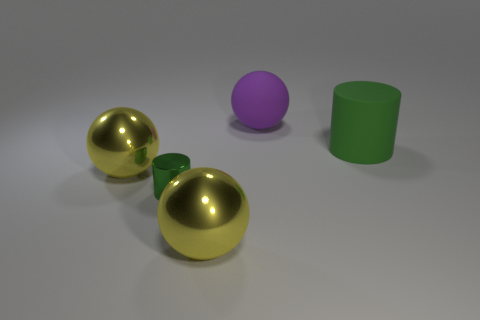Add 5 tiny red metal cylinders. How many objects exist? 10 Subtract all yellow metal balls. How many balls are left? 1 Subtract all balls. How many objects are left? 2 Subtract all purple spheres. How many spheres are left? 2 Subtract 0 red balls. How many objects are left? 5 Subtract 1 cylinders. How many cylinders are left? 1 Subtract all green spheres. Subtract all brown cylinders. How many spheres are left? 3 Subtract all green cylinders. How many purple spheres are left? 1 Subtract all tiny shiny objects. Subtract all tiny cylinders. How many objects are left? 3 Add 5 small green metal things. How many small green metal things are left? 6 